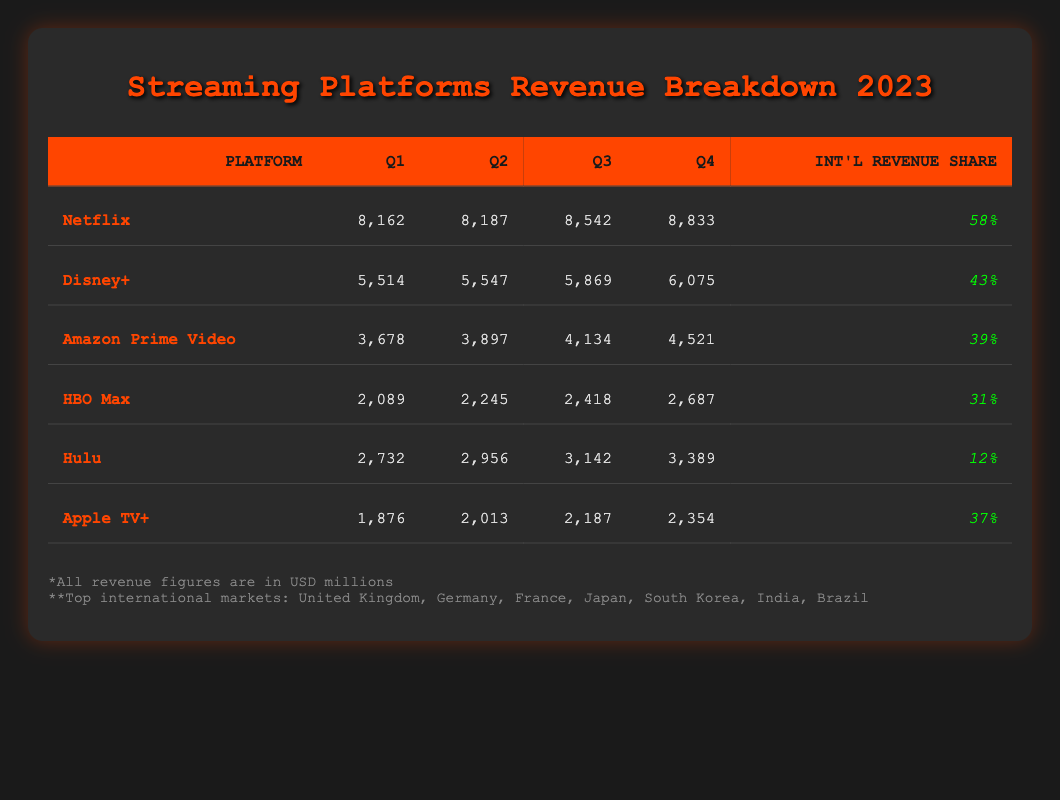What's the total revenue for Netflix in Q3? The table shows that Netflix's revenue for Q3 is listed as 8,542 million USD.
Answer: 8,542 million USD Which platform had the highest revenue in Q4? Looking at the Q4 column in the table, Netflix has the highest revenue at 8,833 million USD, compared to the other platforms.
Answer: Netflix What is the average revenue for Amazon Prime Video across all quarters? The revenues for Amazon Prime Video are 3,678, 3,897, 4,134, and 4,521 million USD. Adding these gives 3,678 + 3,897 + 4,134 + 4,521 = 16,230 million USD. Dividing this by 4 provides the average: 16,230 / 4 = 4,057.5 million USD.
Answer: 4,057.5 million USD Is it true that Hulu has a higher international revenue share than HBO Max? The table shows Hulu's international revenue share as 12% and HBO Max's as 31%. Since 12% is less than 31%, the statement is false.
Answer: No What was the total revenue for Disney+ and Apple TV+ in Q1? Looking at Q1 revenue, Disney+ has 5,514 million USD and Apple TV+ has 1,876 million USD. Summing these gives 5,514 + 1,876 = 7,390 million USD, which is the total for both platforms in Q1.
Answer: 7,390 million USD How much more revenue did Netflix make than Amazon Prime Video in Q2? Netflix's revenue in Q2 is 8,187 million USD, while Amazon Prime Video's is 3,897 million USD. To find the difference, subtract: 8,187 - 3,897 = 4,290 million USD. This shows how much more Netflix earned than Amazon Prime Video in Q2.
Answer: 4,290 million USD What is the revenue growth for HBO Max from Q1 to Q4? The revenue for HBO Max in Q1 is 2,089 million USD and in Q4 is 2,687 million USD. To find the growth, subtract Q1 from Q4: 2,687 - 2,089 = 598 million USD. This represents the revenue increase over that period.
Answer: 598 million USD Did any platform show a decline in revenue from Q1 to Q4? We need to check the revenue figures for each platform from Q1 to Q4. For all platforms including Netflix, Disney+, Amazon Prime Video, HBO Max, Hulu, and Apple TV+, there were no declines, as all the revenues increased in each quarter. Therefore, the answer is no.
Answer: No What is the largest revenue growth percentage among all platforms in 2023? To find this, we need to calculate the percentage growth for each platform from Q1 to Q4. For Netflix: ((8,833 - 8,162) / 8,162) * 100 = 8.22%, for Disney+: ((6,075 - 5,514) / 5,514) * 100 = 10.19%, for Amazon: ((4,521 - 3,678) / 3,678) * 100 = 22.9%, for HBO Max: ((2,687 - 2,089) / 2,089) * 100 = 28.69%, for Hulu: ((3,389 - 2,732) / 2,732) * 100 = 24.08%, and for Apple TV+: ((2,354 - 1,876) / 1,876) * 100 = 25.41%. The largest growth percentage is for HBO Max at 28.69%.
Answer: 28.69% 